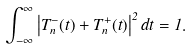<formula> <loc_0><loc_0><loc_500><loc_500>\int _ { - \infty } ^ { \infty } \left | T ^ { - } _ { n } ( t ) + T ^ { + } _ { n } ( t ) \right | ^ { 2 } d t = 1 .</formula> 